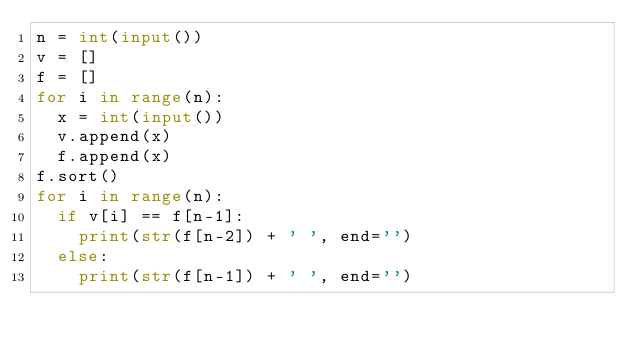<code> <loc_0><loc_0><loc_500><loc_500><_Python_>n = int(input())
v = []
f = []
for i in range(n):
	x = int(input())
	v.append(x)
	f.append(x)
f.sort()
for i in range(n):
	if v[i] == f[n-1]:
		print(str(f[n-2]) + ' ', end='')
	else:
		print(str(f[n-1]) + ' ', end='')	</code> 